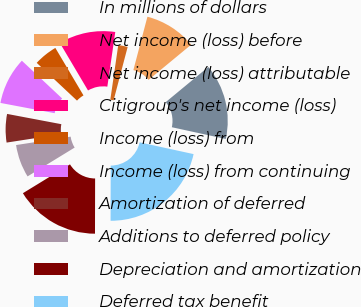Convert chart. <chart><loc_0><loc_0><loc_500><loc_500><pie_chart><fcel>In millions of dollars<fcel>Net income (loss) before<fcel>Net income (loss) attributable<fcel>Citigroup's net income (loss)<fcel>Income (loss) from<fcel>Income (loss) from continuing<fcel>Amortization of deferred<fcel>Additions to deferred policy<fcel>Depreciation and amortization<fcel>Deferred tax benefit<nl><fcel>14.41%<fcel>9.91%<fcel>1.8%<fcel>10.81%<fcel>4.5%<fcel>9.01%<fcel>5.41%<fcel>6.31%<fcel>16.22%<fcel>21.62%<nl></chart> 